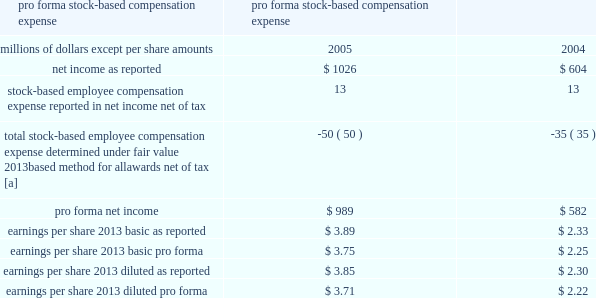Stock-based compensation 2013 we have several stock-based compensation plans under which employees and non-employee directors receive stock options , nonvested retention shares , and nonvested stock units .
We refer to the nonvested shares and stock units collectively as 201cretention awards 201d .
We issue treasury shares to cover option exercises and stock unit vestings , while new shares are issued when retention shares vest .
We adopted fasb statement no .
123 ( r ) , share-based payment ( fas 123 ( r ) ) , on january 1 , 2006 .
Fas 123 ( r ) requires us to measure and recognize compensation expense for all stock-based awards made to employees and directors , including stock options .
Compensation expense is based on the calculated fair value of the awards as measured at the grant date and is expensed ratably over the service period of the awards ( generally the vesting period ) .
The fair value of retention awards is the stock price on the date of grant , while the fair value of stock options is determined by using the black-scholes option pricing model .
We elected to use the modified prospective transition method as permitted by fas 123 ( r ) and did not restate financial results for prior periods .
We did not make an adjustment for the cumulative effect of these estimated forfeitures , as the impact was not material .
As a result of the adoption of fas 123 ( r ) , we recognized expense for stock options in 2006 , in addition to retention awards , which were expensed prior to 2006 .
Stock-based compensation expense for the year ended december 31 , 2006 was $ 22 million , after tax , or $ 0.08 per basic and diluted share .
This includes $ 9 million for stock options and $ 13 million for retention awards for 2006 .
Before taxes , stock-based compensation expense included $ 14 million for stock options and $ 21 million for retention awards for 2006 .
We recorded $ 29 million of excess tax benefits as an inflow of financing activities in the consolidated statement of cash flows for the year ended december 31 , 2006 .
Prior to the adoption of fas 123 ( r ) , we applied the recognition and measurement principles of accounting principles board opinion no .
25 , accounting for stock issued to employees , and related interpretations .
No stock- based employee compensation expense related to stock option grants was reflected in net income , as all options granted under those plans had a grant price equal to the market value of our common stock on the date of grant .
Stock-based compensation expense related to retention shares , stock units , and other incentive plans was reflected in net income .
The table details the effect on net income and earnings per share had compensation expense for all of our stock-based awards , including stock options , been recorded in the years ended december 31 , 2005 and 2004 based on the fair value method under fasb statement no .
123 , accounting for stock-based compensation .
Pro forma stock-based compensation expense year ended december 31 , millions of dollars , except per share amounts 2005 2004 .
[a] stock options for executives granted in 2003 and 2002 included a reload feature .
This reload feature allowed executives to exercise their options using shares of union pacific corporation common stock that they already owned and obtain a new grant of options in the amount of the shares used for exercise plus any shares withheld for tax purposes .
The reload feature of these option grants could only be exercised if the .
What was the percentage difference of earnings per share 2013 basic pro forma compared to earnings per share 2013 diluted pro forma in 2004? 
Computations: ((2.25 - 2.22) / 2.25)
Answer: 0.01333. 